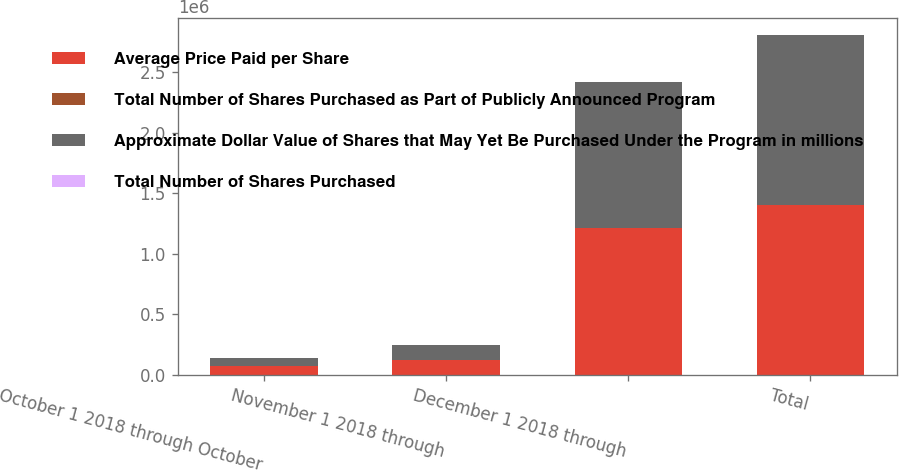<chart> <loc_0><loc_0><loc_500><loc_500><stacked_bar_chart><ecel><fcel>October 1 2018 through October<fcel>November 1 2018 through<fcel>December 1 2018 through<fcel>Total<nl><fcel>Average Price Paid per Share<fcel>69516<fcel>122406<fcel>1.21136e+06<fcel>1.40329e+06<nl><fcel>Total Number of Shares Purchased as Part of Publicly Announced Program<fcel>239.71<fcel>215.4<fcel>192.19<fcel>196.57<nl><fcel>Approximate Dollar Value of Shares that May Yet Be Purchased Under the Program in millions<fcel>69516<fcel>122406<fcel>1.21136e+06<fcel>1.40329e+06<nl><fcel>Total Number of Shares Purchased<fcel>699.7<fcel>673.3<fcel>440.5<fcel>440.5<nl></chart> 